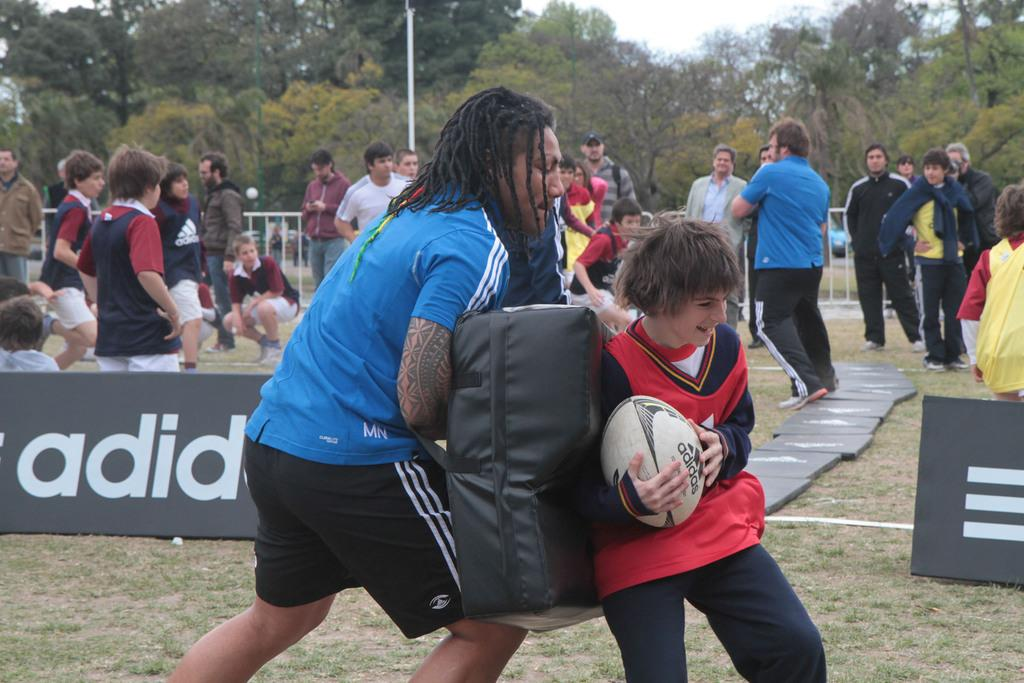What is the boy holding in the image? The boy is holding a ball. How are most people positioned in the image? Most people are standing. Can you describe the position of one person in the image? One person is in a squat position. What can be seen in the background of the image? There are multiple trees in the distance. What nation is being led by the person in the squat position in the image? There is no indication of a nation or leadership role in the image; it simply shows people in various positions and a boy holding a ball. 